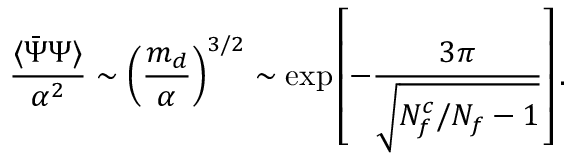Convert formula to latex. <formula><loc_0><loc_0><loc_500><loc_500>{ \frac { \langle \bar { \Psi } \Psi \rangle } { \alpha ^ { 2 } } } \sim \left ( { \frac { m _ { d } } { \alpha } } \right ) ^ { 3 / 2 } \sim \exp \left [ - { \frac { 3 \pi } { \sqrt { N _ { f } ^ { c } / N _ { f } - 1 } } } \right ] .</formula> 